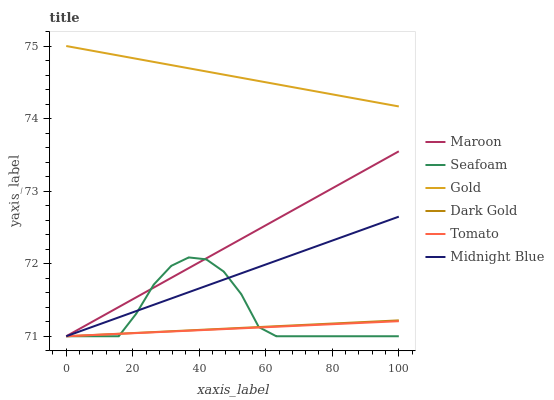Does Tomato have the minimum area under the curve?
Answer yes or no. Yes. Does Gold have the maximum area under the curve?
Answer yes or no. Yes. Does Midnight Blue have the minimum area under the curve?
Answer yes or no. No. Does Midnight Blue have the maximum area under the curve?
Answer yes or no. No. Is Midnight Blue the smoothest?
Answer yes or no. Yes. Is Seafoam the roughest?
Answer yes or no. Yes. Is Gold the smoothest?
Answer yes or no. No. Is Gold the roughest?
Answer yes or no. No. Does Tomato have the lowest value?
Answer yes or no. Yes. Does Gold have the lowest value?
Answer yes or no. No. Does Gold have the highest value?
Answer yes or no. Yes. Does Midnight Blue have the highest value?
Answer yes or no. No. Is Midnight Blue less than Gold?
Answer yes or no. Yes. Is Gold greater than Maroon?
Answer yes or no. Yes. Does Maroon intersect Dark Gold?
Answer yes or no. Yes. Is Maroon less than Dark Gold?
Answer yes or no. No. Is Maroon greater than Dark Gold?
Answer yes or no. No. Does Midnight Blue intersect Gold?
Answer yes or no. No. 